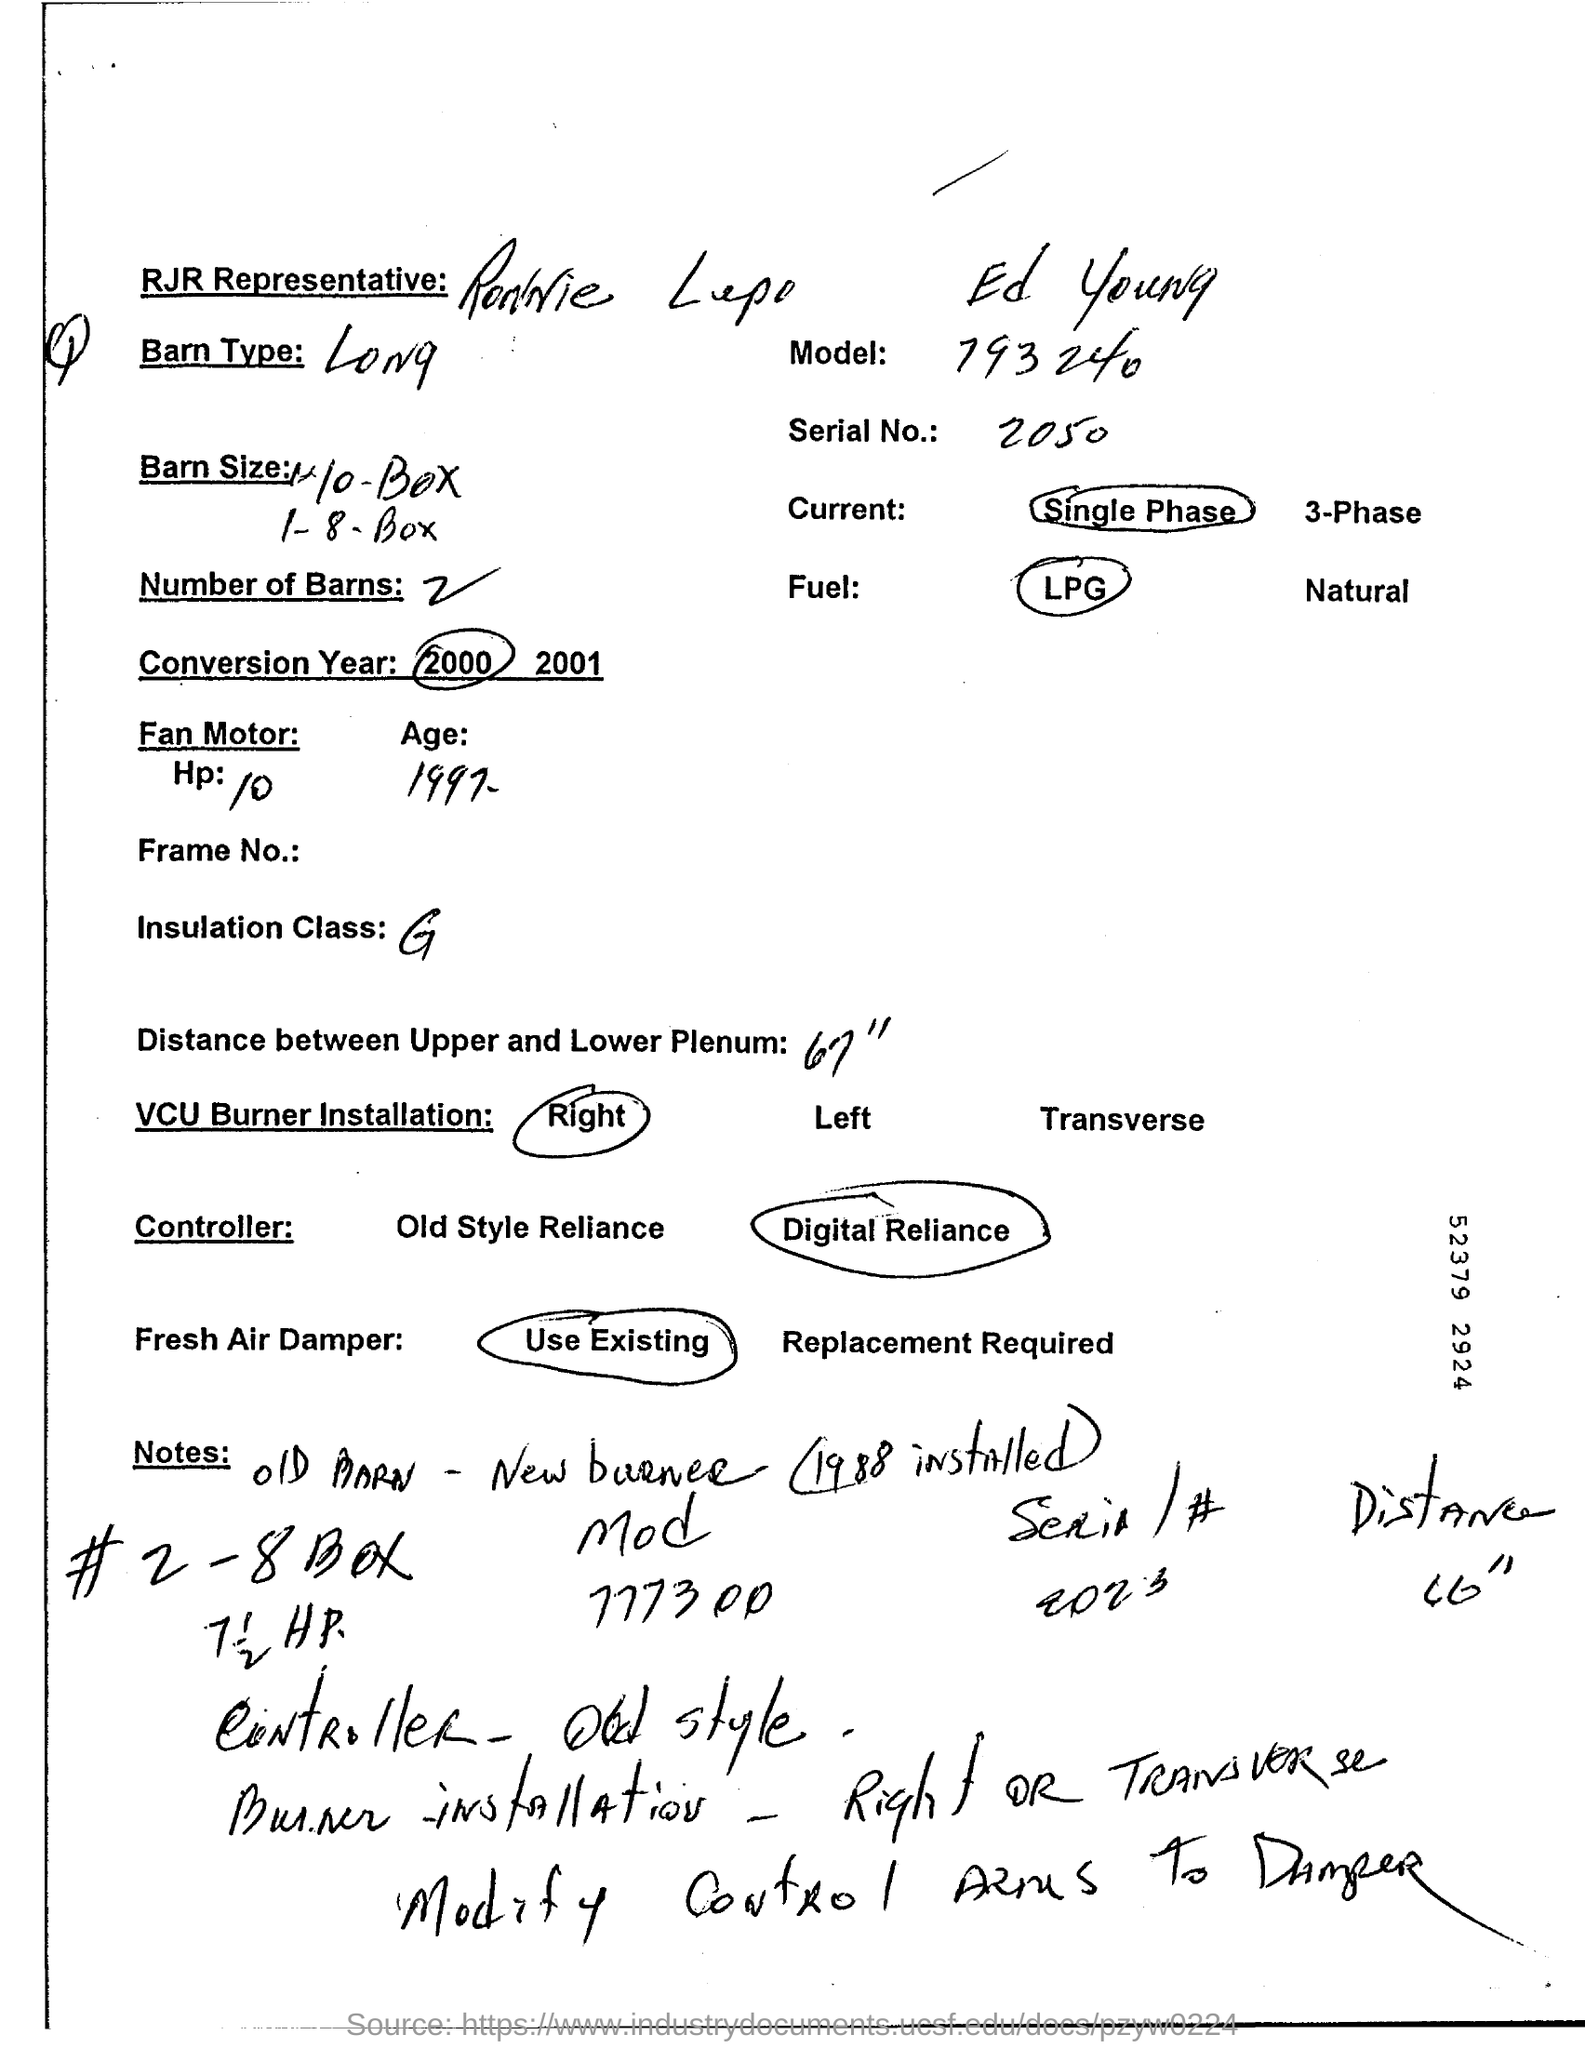What is model number written in page?
Ensure brevity in your answer.  793 240. What is serial no?
Your answer should be compact. 2050. 